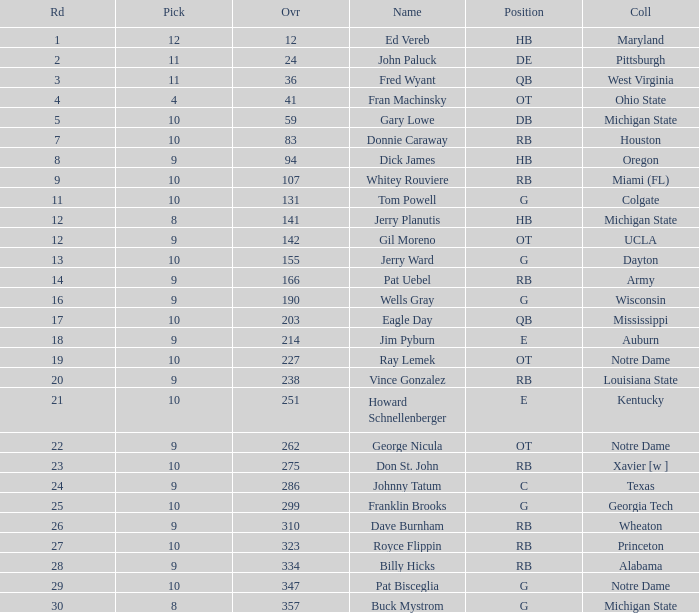What is the sum of rounds that has a pick of 9 and is named jim pyburn? 18.0. 